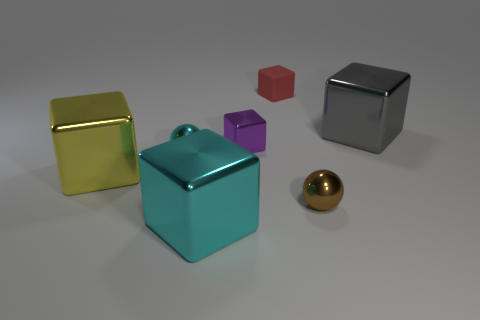Is the number of purple shiny things that are behind the brown metal thing greater than the number of cyan metallic objects behind the small purple object?
Your answer should be very brief. Yes. What number of other things are there of the same color as the small matte object?
Provide a short and direct response. 0. There is a sphere to the left of the tiny brown thing; how many small metallic things are in front of it?
Provide a succinct answer. 1. Are there any other things that are made of the same material as the red thing?
Offer a terse response. No. What is the material of the tiny cube behind the small cube in front of the large metallic block behind the small purple shiny thing?
Your answer should be very brief. Rubber. There is a tiny object that is both in front of the small purple object and behind the yellow cube; what is its material?
Your answer should be compact. Metal. What number of large gray things have the same shape as the brown object?
Offer a terse response. 0. What size is the ball that is on the right side of the small sphere to the left of the large cyan cube?
Offer a very short reply. Small. There is a big metal thing that is in front of the big yellow cube; is it the same color as the sphere behind the large yellow block?
Ensure brevity in your answer.  Yes. There is a tiny block that is left of the tiny red object that is to the left of the small brown shiny sphere; what number of small purple blocks are to the right of it?
Offer a very short reply. 0. 